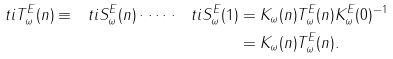<formula> <loc_0><loc_0><loc_500><loc_500>\ t i { T } ^ { E } _ { \omega } ( n ) \equiv \ t i { S } ^ { E } _ { \omega } ( n ) \cdot \dots \cdot \ t i { S } ^ { E } _ { \omega } ( 1 ) & = K _ { \omega } ( n ) T ^ { E } _ { \omega } ( n ) K ^ { E } _ { \omega } ( 0 ) ^ { - 1 } \\ & = K _ { \omega } ( n ) T ^ { E } _ { \omega } ( n ) .</formula> 